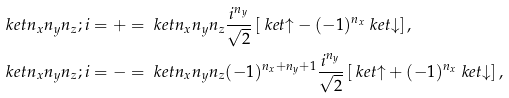<formula> <loc_0><loc_0><loc_500><loc_500>\ k e t { n _ { x } n _ { y } n _ { z } ; i = + } & = \ k e t { n _ { x } n _ { y } n _ { z } } \frac { i ^ { n _ { y } } } { \sqrt { 2 } } \left [ \ k e t { \uparrow } - ( - 1 ) ^ { n _ { x } } \ k e t { \downarrow } \right ] , \\ \ k e t { n _ { x } n _ { y } n _ { z } ; i = - } & = \ k e t { n _ { x } n _ { y } n _ { z } } ( - 1 ) ^ { n _ { x } + n _ { y } + 1 } \frac { i ^ { n _ { y } } } { \sqrt { 2 } } \left [ \ k e t { \uparrow } + ( - 1 ) ^ { n _ { x } } \ k e t { \downarrow } \right ] ,</formula> 